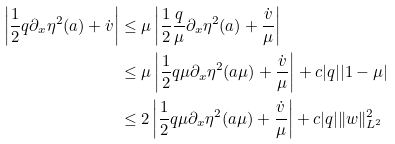Convert formula to latex. <formula><loc_0><loc_0><loc_500><loc_500>\left | \frac { 1 } { 2 } q \partial _ { x } \eta ^ { 2 } ( a ) + \dot { v } \right | & \leq \mu \left | \frac { 1 } { 2 } \frac { q } { \mu } \partial _ { x } \eta ^ { 2 } ( a ) + \frac { \dot { v } } \mu \right | \\ & \leq \mu \left | \frac { 1 } { 2 } q \mu \partial _ { x } \eta ^ { 2 } ( a \mu ) + \frac { \dot { v } } { \mu } \right | + c | q | | 1 - \mu | \\ & \leq 2 \left | \frac { 1 } { 2 } q \mu \partial _ { x } \eta ^ { 2 } ( a \mu ) + \frac { \dot { v } } { \mu } \right | + c | q | \| w \| _ { L ^ { 2 } } ^ { 2 }</formula> 